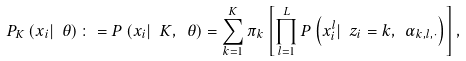<formula> <loc_0><loc_0><loc_500><loc_500>P _ { K } \left ( x _ { i } | \ \theta \right ) \colon = P \left ( x _ { i } | \ K , \ \theta \right ) = \sum _ { k = 1 } ^ { K } \pi _ { k } \left [ \prod _ { l = 1 } ^ { L } P \left ( x _ { i } ^ { l } | \ z _ { i } = k , \ \alpha _ { k , l , \cdot } \right ) \right ] ,</formula> 